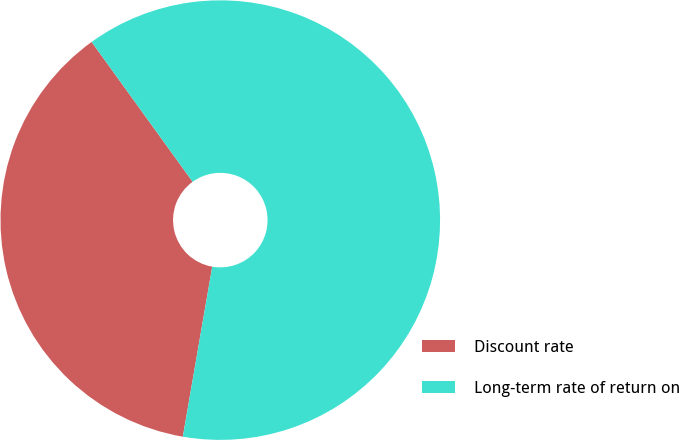Convert chart to OTSL. <chart><loc_0><loc_0><loc_500><loc_500><pie_chart><fcel>Discount rate<fcel>Long-term rate of return on<nl><fcel>37.32%<fcel>62.68%<nl></chart> 